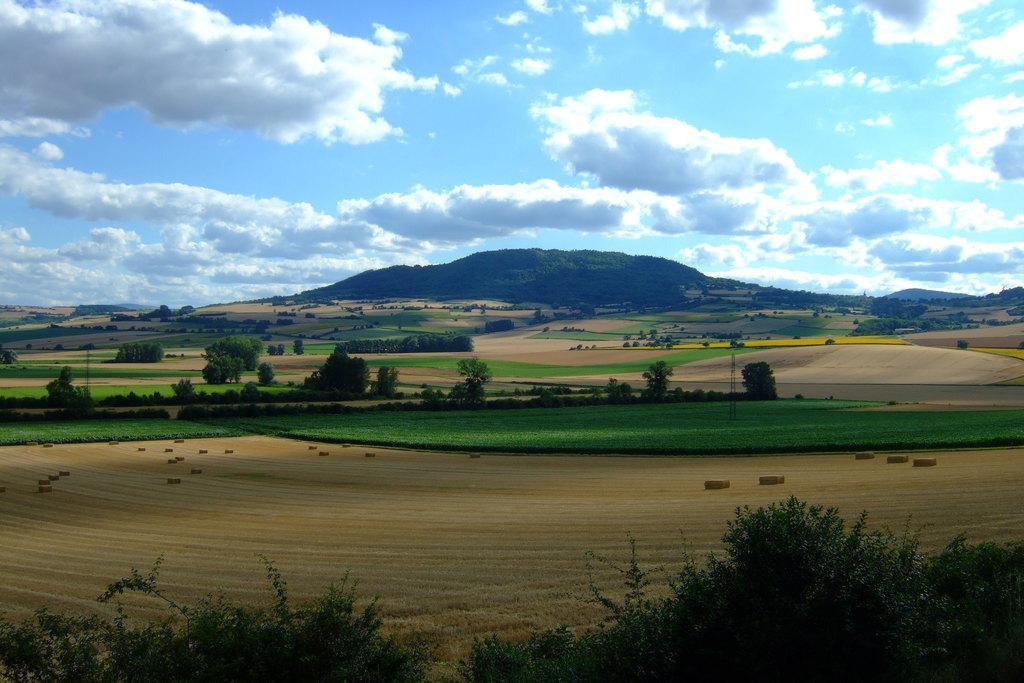In one or two sentences, can you explain what this image depicts? In the foreground of the picture there are trees and crop. In the center of the picture there are trees and fields. In the background there is a hill covered with trees. Sky is cloudy. 